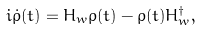Convert formula to latex. <formula><loc_0><loc_0><loc_500><loc_500>i \dot { \rho } ( t ) = H _ { w } \rho ( t ) - \rho ( t ) H _ { w } ^ { \dagger } ,</formula> 